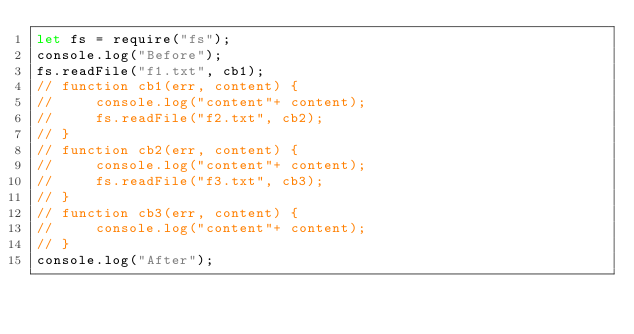<code> <loc_0><loc_0><loc_500><loc_500><_JavaScript_>let fs = require("fs");
console.log("Before");
fs.readFile("f1.txt", cb1);
// function cb1(err, content) {
//     console.log("content"+ content);
//     fs.readFile("f2.txt", cb2);
// }
// function cb2(err, content) {
//     console.log("content"+ content);
//     fs.readFile("f3.txt", cb3);
// }
// function cb3(err, content) {
//     console.log("content"+ content);
// }
console.log("After");
</code> 